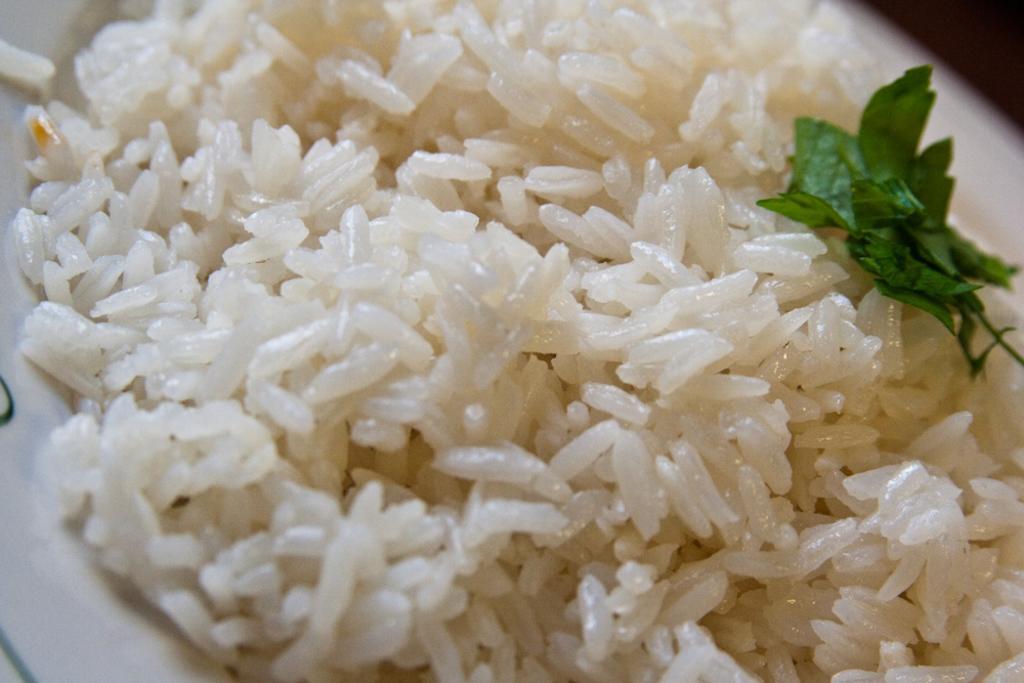Could you give a brief overview of what you see in this image? In this picture there is rice in a plate. 